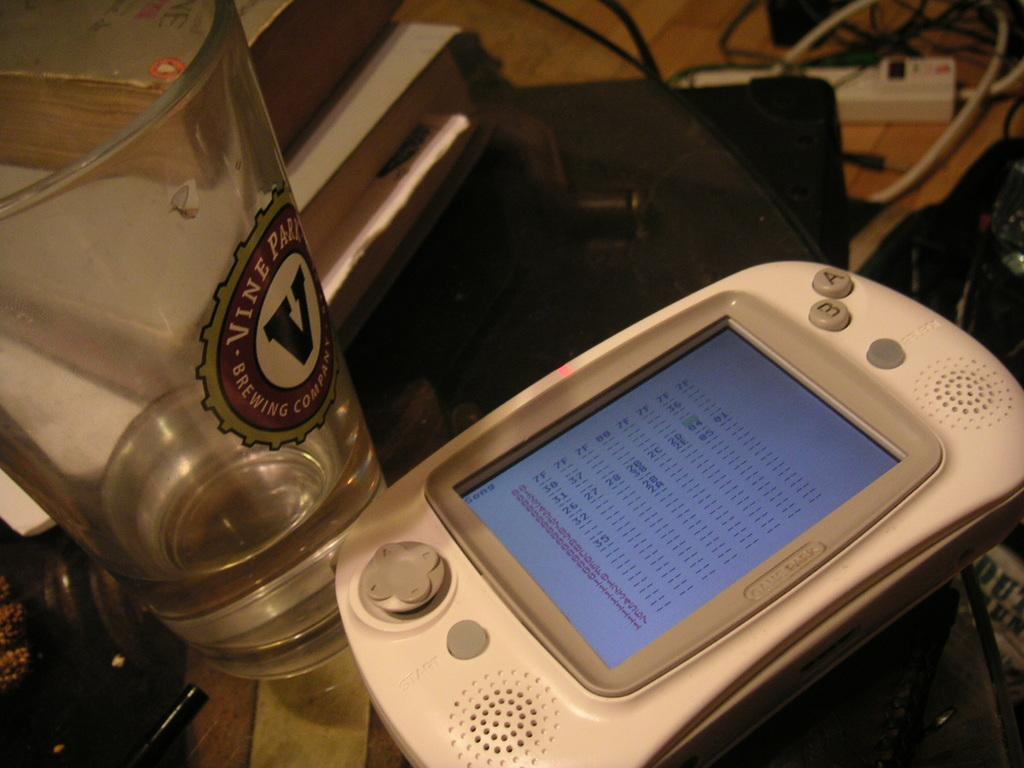<image>
Summarize the visual content of the image. Vine Park brewing company is stamped in red and black on a glass. 